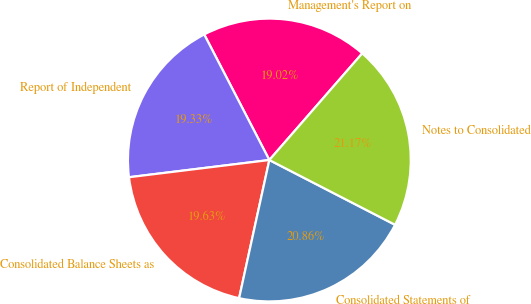Convert chart to OTSL. <chart><loc_0><loc_0><loc_500><loc_500><pie_chart><fcel>Management's Report on<fcel>Report of Independent<fcel>Consolidated Balance Sheets as<fcel>Consolidated Statements of<fcel>Notes to Consolidated<nl><fcel>19.02%<fcel>19.33%<fcel>19.63%<fcel>20.86%<fcel>21.17%<nl></chart> 